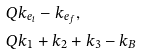Convert formula to latex. <formula><loc_0><loc_0><loc_500><loc_500>Q & k _ { e _ { i } } - k _ { e _ { f } } , \\ Q & k _ { 1 } + k _ { 2 } + k _ { 3 } - k _ { B }</formula> 